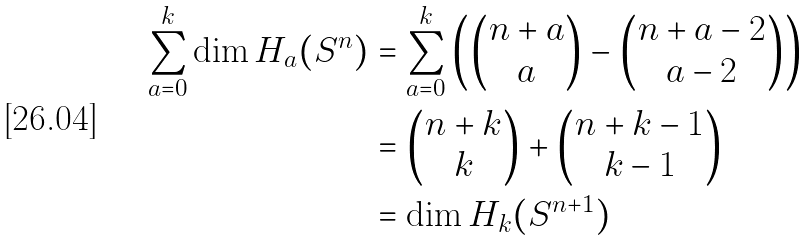Convert formula to latex. <formula><loc_0><loc_0><loc_500><loc_500>\sum _ { a = 0 } ^ { k } \dim H _ { a } ( S ^ { n } ) & = \sum _ { a = 0 } ^ { k } \begin{pmatrix} \begin{pmatrix} n + a \\ a \end{pmatrix} - \begin{pmatrix} n + a - 2 \\ a - 2 \end{pmatrix} \end{pmatrix} \\ & = \begin{pmatrix} n + k \\ k \end{pmatrix} + \begin{pmatrix} n + k - 1 \\ k - 1 \end{pmatrix} \\ & = \dim H _ { k } ( S ^ { n + 1 } )</formula> 